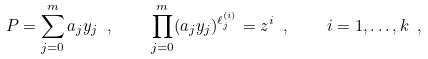<formula> <loc_0><loc_0><loc_500><loc_500>P = \sum _ { j = 0 } ^ { m } a _ { j } y _ { j } \ , \quad \prod _ { j = 0 } ^ { m } ( a _ { j } y _ { j } ) ^ { \ell ^ { ( i ) } _ { j } } = z ^ { i } \ , \quad i = 1 , \dots , k \ ,</formula> 